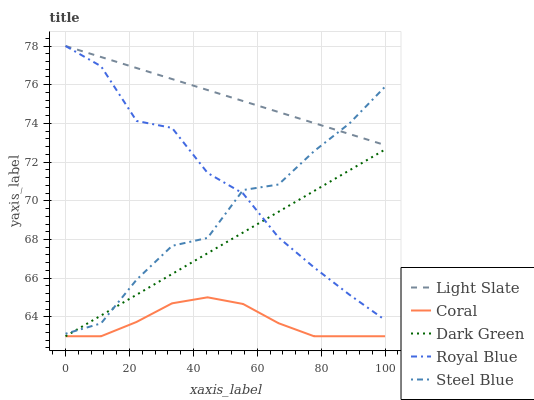Does Coral have the minimum area under the curve?
Answer yes or no. Yes. Does Light Slate have the maximum area under the curve?
Answer yes or no. Yes. Does Royal Blue have the minimum area under the curve?
Answer yes or no. No. Does Royal Blue have the maximum area under the curve?
Answer yes or no. No. Is Light Slate the smoothest?
Answer yes or no. Yes. Is Steel Blue the roughest?
Answer yes or no. Yes. Is Royal Blue the smoothest?
Answer yes or no. No. Is Royal Blue the roughest?
Answer yes or no. No. Does Royal Blue have the lowest value?
Answer yes or no. No. Does Royal Blue have the highest value?
Answer yes or no. Yes. Does Coral have the highest value?
Answer yes or no. No. Is Coral less than Steel Blue?
Answer yes or no. Yes. Is Light Slate greater than Coral?
Answer yes or no. Yes. Does Steel Blue intersect Dark Green?
Answer yes or no. Yes. Is Steel Blue less than Dark Green?
Answer yes or no. No. Is Steel Blue greater than Dark Green?
Answer yes or no. No. Does Coral intersect Steel Blue?
Answer yes or no. No. 